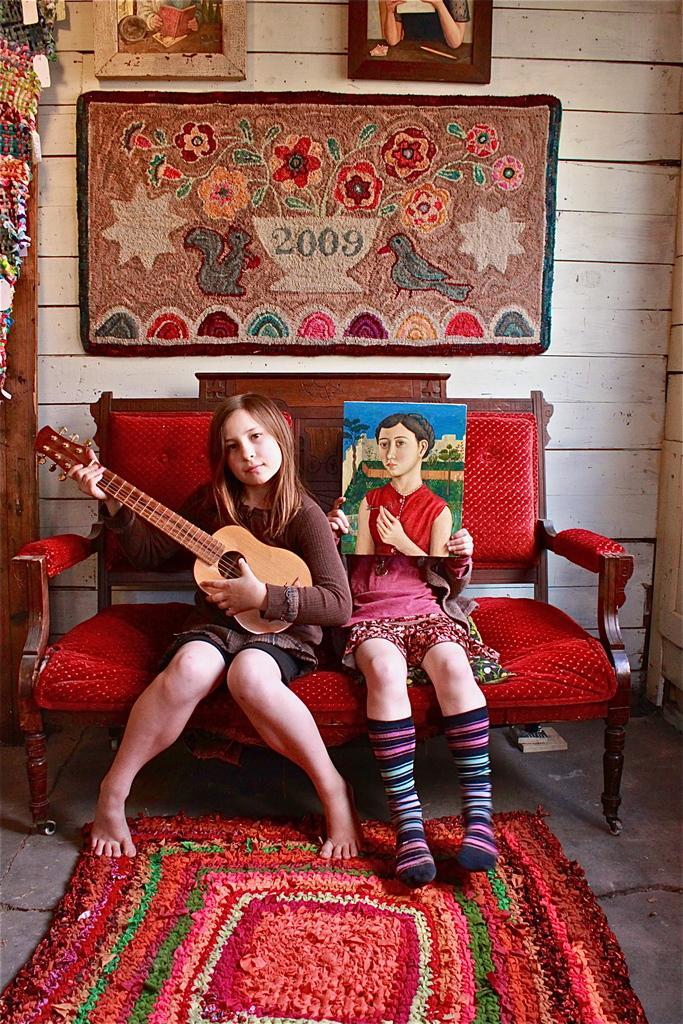Can you describe this image briefly? In this picture there are two girls sitting on a couch one girl is holding a guitar and another careless holding a painting frame back side we can see a painted frame and tomorrow frames to the wall and on the floor we can see a colorful mat 